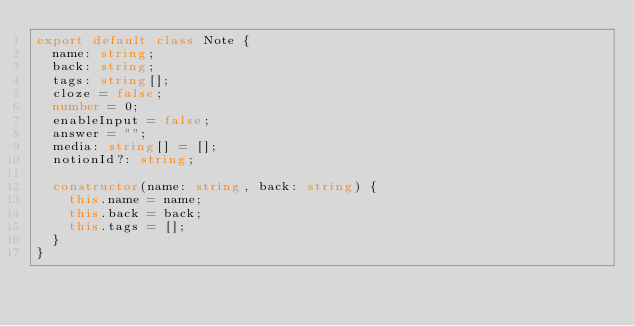<code> <loc_0><loc_0><loc_500><loc_500><_TypeScript_>export default class Note {
  name: string;
  back: string;
  tags: string[];
  cloze = false;
  number = 0;
  enableInput = false;
  answer = "";
  media: string[] = [];
  notionId?: string;

  constructor(name: string, back: string) {
    this.name = name;
    this.back = back;
    this.tags = [];
  }
}
</code> 